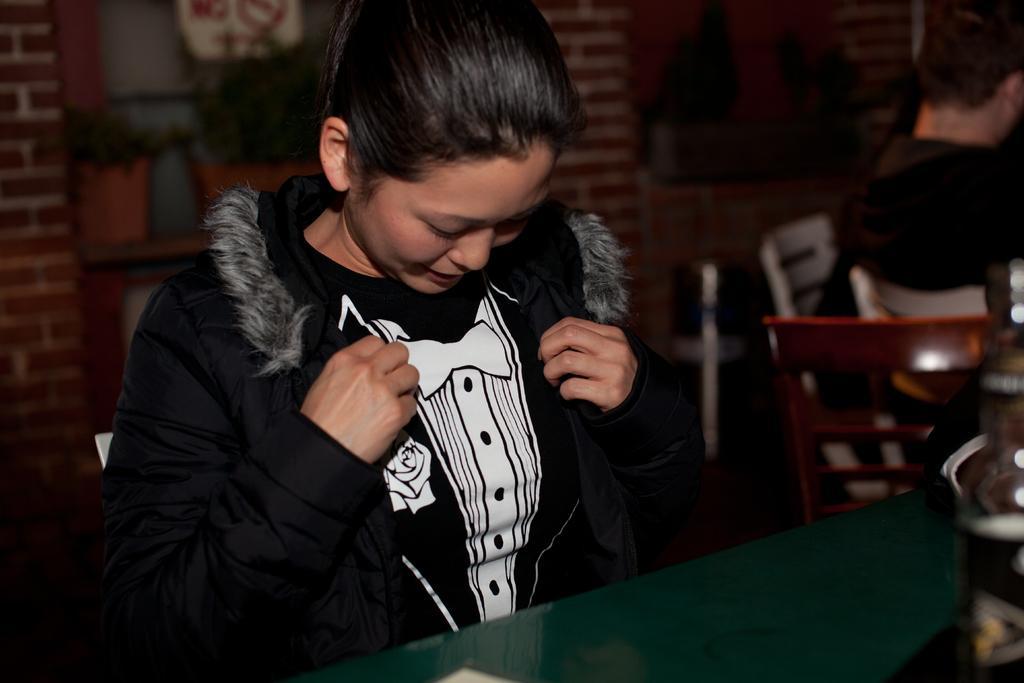Please provide a concise description of this image. In the given image we can see a girl wearing black color jacket. These are the chairs. 